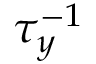<formula> <loc_0><loc_0><loc_500><loc_500>\tau _ { y } ^ { - 1 }</formula> 